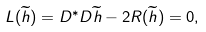Convert formula to latex. <formula><loc_0><loc_0><loc_500><loc_500>L ( \widetilde { h } ) = D ^ { * } D \widetilde { h } - 2 R ( \widetilde { h } ) = 0 ,</formula> 